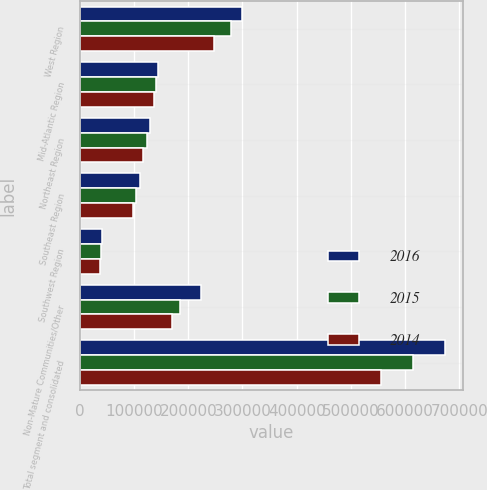Convert chart. <chart><loc_0><loc_0><loc_500><loc_500><stacked_bar_chart><ecel><fcel>West Region<fcel>Mid­Atlantic Region<fcel>Northeast Region<fcel>Southeast Region<fcel>Southwest Region<fcel>Non­Mature Communities/Other<fcel>Total segment and consolidated<nl><fcel>2016<fcel>298469<fcel>144069<fcel>130285<fcel>111318<fcel>41273<fcel>223047<fcel>673085<nl><fcel>2015<fcel>278602<fcel>140423<fcel>124478<fcel>103920<fcel>39166<fcel>185339<fcel>613869<nl><fcel>2014<fcel>246764<fcel>136786<fcel>115981<fcel>98060<fcel>37139<fcel>170419<fcel>556321<nl></chart> 